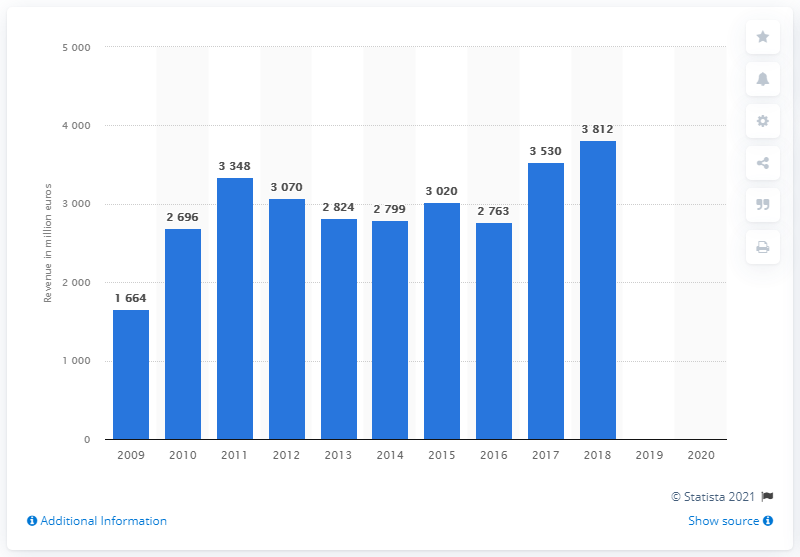Outline some significant characteristics in this image. Nyrstar was last in a fiscal year in 2009. In the fiscal year of 2018, Nyrstar generated a revenue of 3812. 